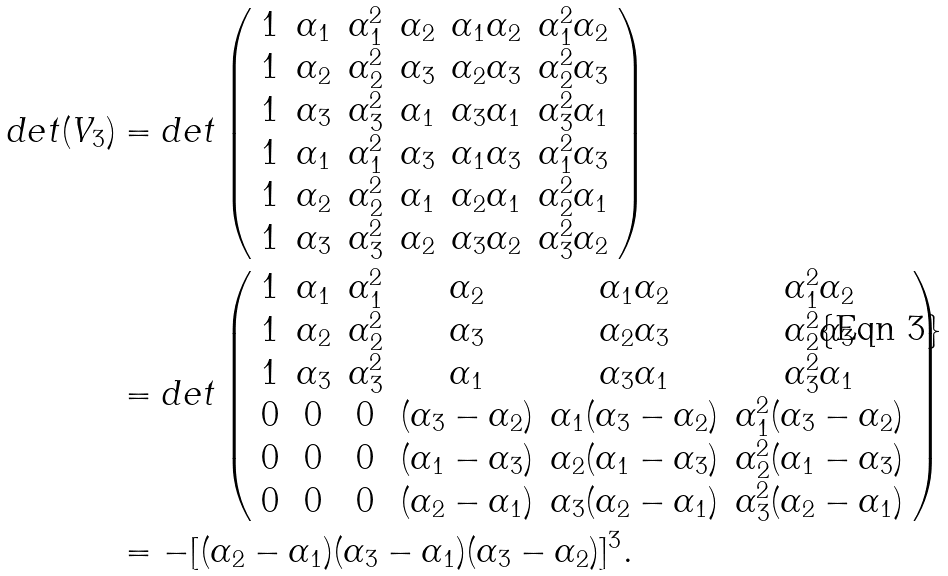<formula> <loc_0><loc_0><loc_500><loc_500>d e t ( V _ { 3 } ) & = d e t \left ( \begin{array} { c c c c c c } 1 & \alpha _ { 1 } & \alpha _ { 1 } ^ { 2 } & \alpha _ { 2 } & \alpha _ { 1 } \alpha _ { 2 } & \alpha _ { 1 } ^ { 2 } \alpha _ { 2 } \\ 1 & \alpha _ { 2 } & \alpha _ { 2 } ^ { 2 } & \alpha _ { 3 } & \alpha _ { 2 } \alpha _ { 3 } & \alpha _ { 2 } ^ { 2 } \alpha _ { 3 } \\ 1 & \alpha _ { 3 } & \alpha _ { 3 } ^ { 2 } & \alpha _ { 1 } & \alpha _ { 3 } \alpha _ { 1 } & \alpha _ { 3 } ^ { 2 } \alpha _ { 1 } \\ 1 & \alpha _ { 1 } & \alpha _ { 1 } ^ { 2 } & \alpha _ { 3 } & \alpha _ { 1 } \alpha _ { 3 } & \alpha _ { 1 } ^ { 2 } \alpha _ { 3 } \\ 1 & \alpha _ { 2 } & \alpha _ { 2 } ^ { 2 } & \alpha _ { 1 } & \alpha _ { 2 } \alpha _ { 1 } & \alpha _ { 2 } ^ { 2 } \alpha _ { 1 } \\ 1 & \alpha _ { 3 } & \alpha _ { 3 } ^ { 2 } & \alpha _ { 2 } & \alpha _ { 3 } \alpha _ { 2 } & \alpha _ { 3 } ^ { 2 } \alpha _ { 2 } \\ \end{array} \right ) \\ & = d e t \left ( \begin{array} { c c c c c c } 1 & \alpha _ { 1 } & \alpha _ { 1 } ^ { 2 } & \alpha _ { 2 } & \alpha _ { 1 } \alpha _ { 2 } & \alpha _ { 1 } ^ { 2 } \alpha _ { 2 } \\ 1 & \alpha _ { 2 } & \alpha _ { 2 } ^ { 2 } & \alpha _ { 3 } & \alpha _ { 2 } \alpha _ { 3 } & \alpha _ { 2 } ^ { 2 } \alpha _ { 3 } \\ 1 & \alpha _ { 3 } & \alpha _ { 3 } ^ { 2 } & \alpha _ { 1 } & \alpha _ { 3 } \alpha _ { 1 } & \alpha _ { 3 } ^ { 2 } \alpha _ { 1 } \\ 0 & 0 & 0 & ( \alpha _ { 3 } - \alpha _ { 2 } ) & \alpha _ { 1 } ( \alpha _ { 3 } - \alpha _ { 2 } ) & \alpha _ { 1 } ^ { 2 } ( \alpha _ { 3 } - \alpha _ { 2 } ) \\ 0 & 0 & 0 & ( \alpha _ { 1 } - \alpha _ { 3 } ) & \alpha _ { 2 } ( \alpha _ { 1 } - \alpha _ { 3 } ) & \alpha _ { 2 } ^ { 2 } ( \alpha _ { 1 } - \alpha _ { 3 } ) \\ 0 & 0 & 0 & ( \alpha _ { 2 } - \alpha _ { 1 } ) & \alpha _ { 3 } ( \alpha _ { 2 } - \alpha _ { 1 } ) & \alpha _ { 3 } ^ { 2 } ( \alpha _ { 2 } - \alpha _ { 1 } ) \\ \end{array} \right ) \\ & = - [ ( \alpha _ { 2 } - \alpha _ { 1 } ) ( \alpha _ { 3 } - \alpha _ { 1 } ) ( \alpha _ { 3 } - \alpha _ { 2 } ) ] ^ { 3 } .</formula> 